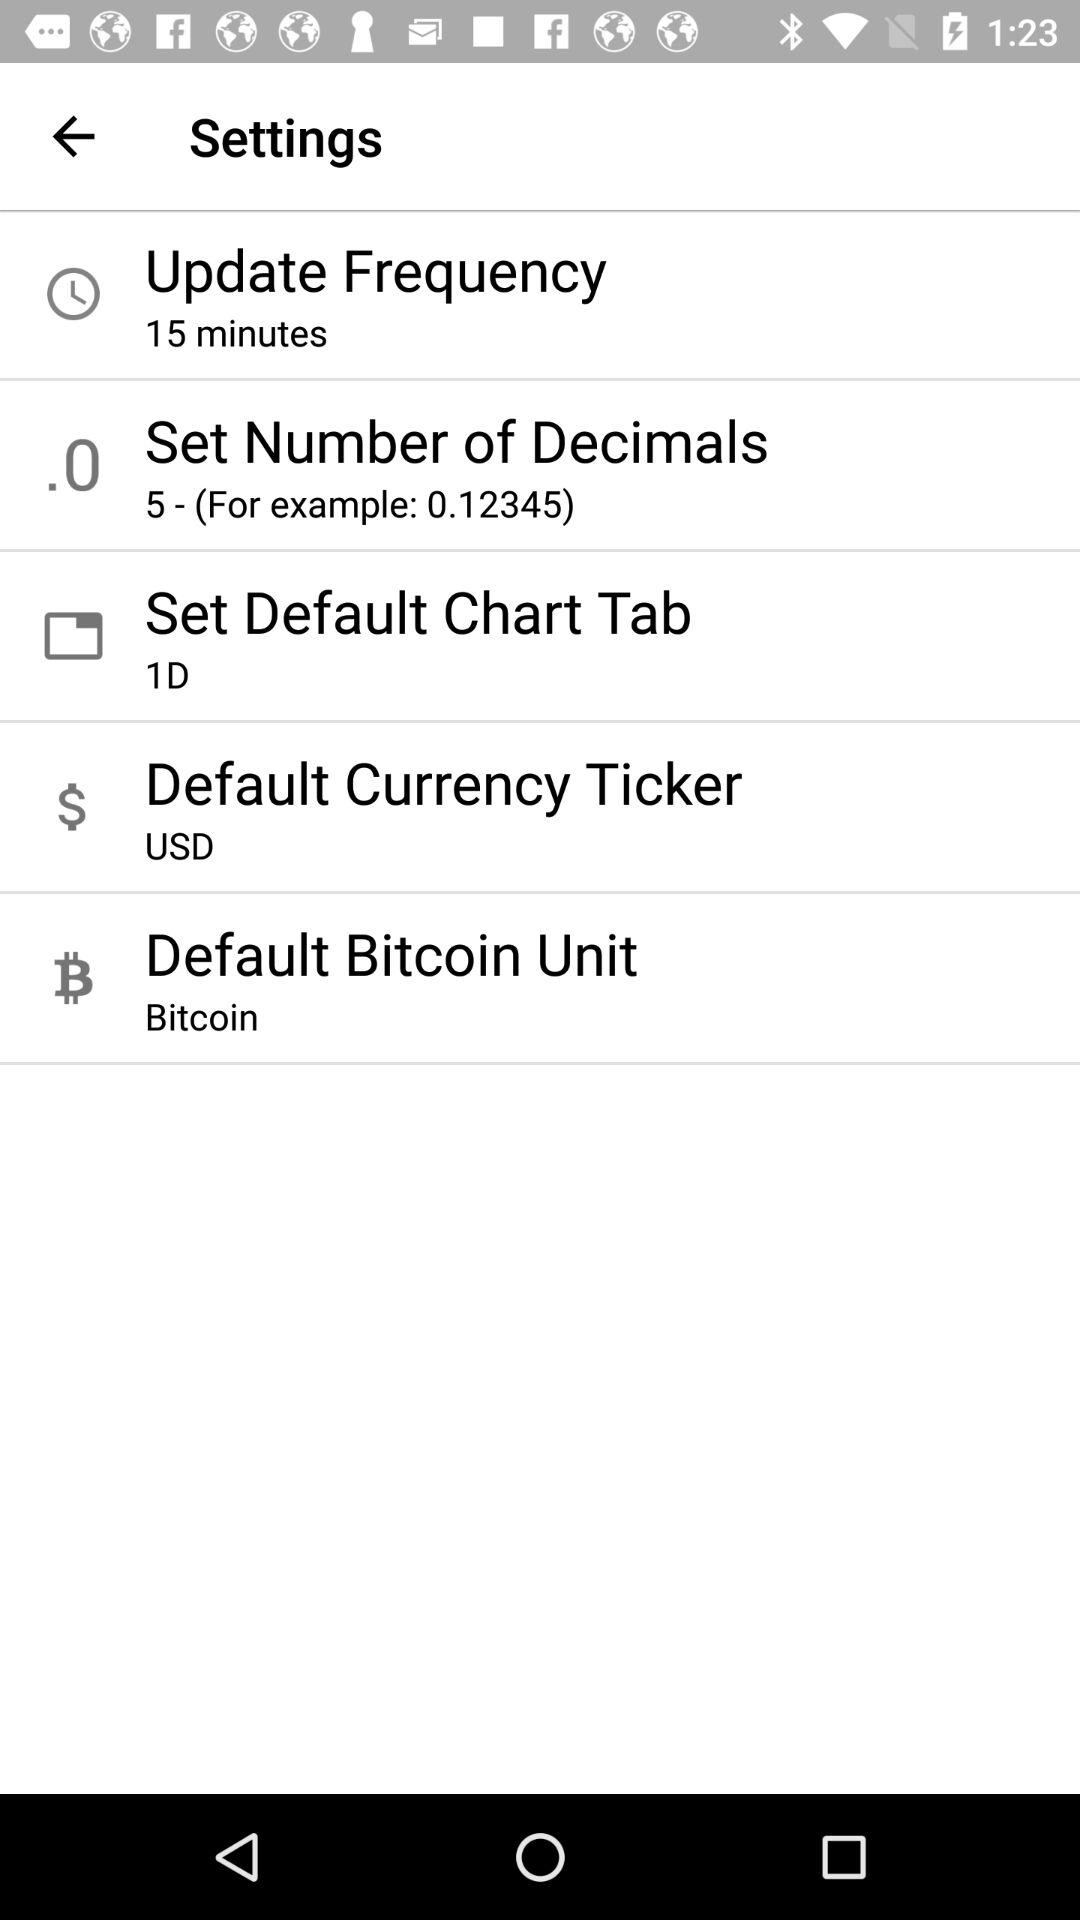How many decimals are available to choose from?
Answer the question using a single word or phrase. 5 